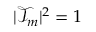<formula> <loc_0><loc_0><loc_500><loc_500>| \mathcal { T } _ { m } | ^ { 2 } = 1</formula> 